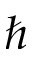Convert formula to latex. <formula><loc_0><loc_0><loc_500><loc_500>\hbar</formula> 